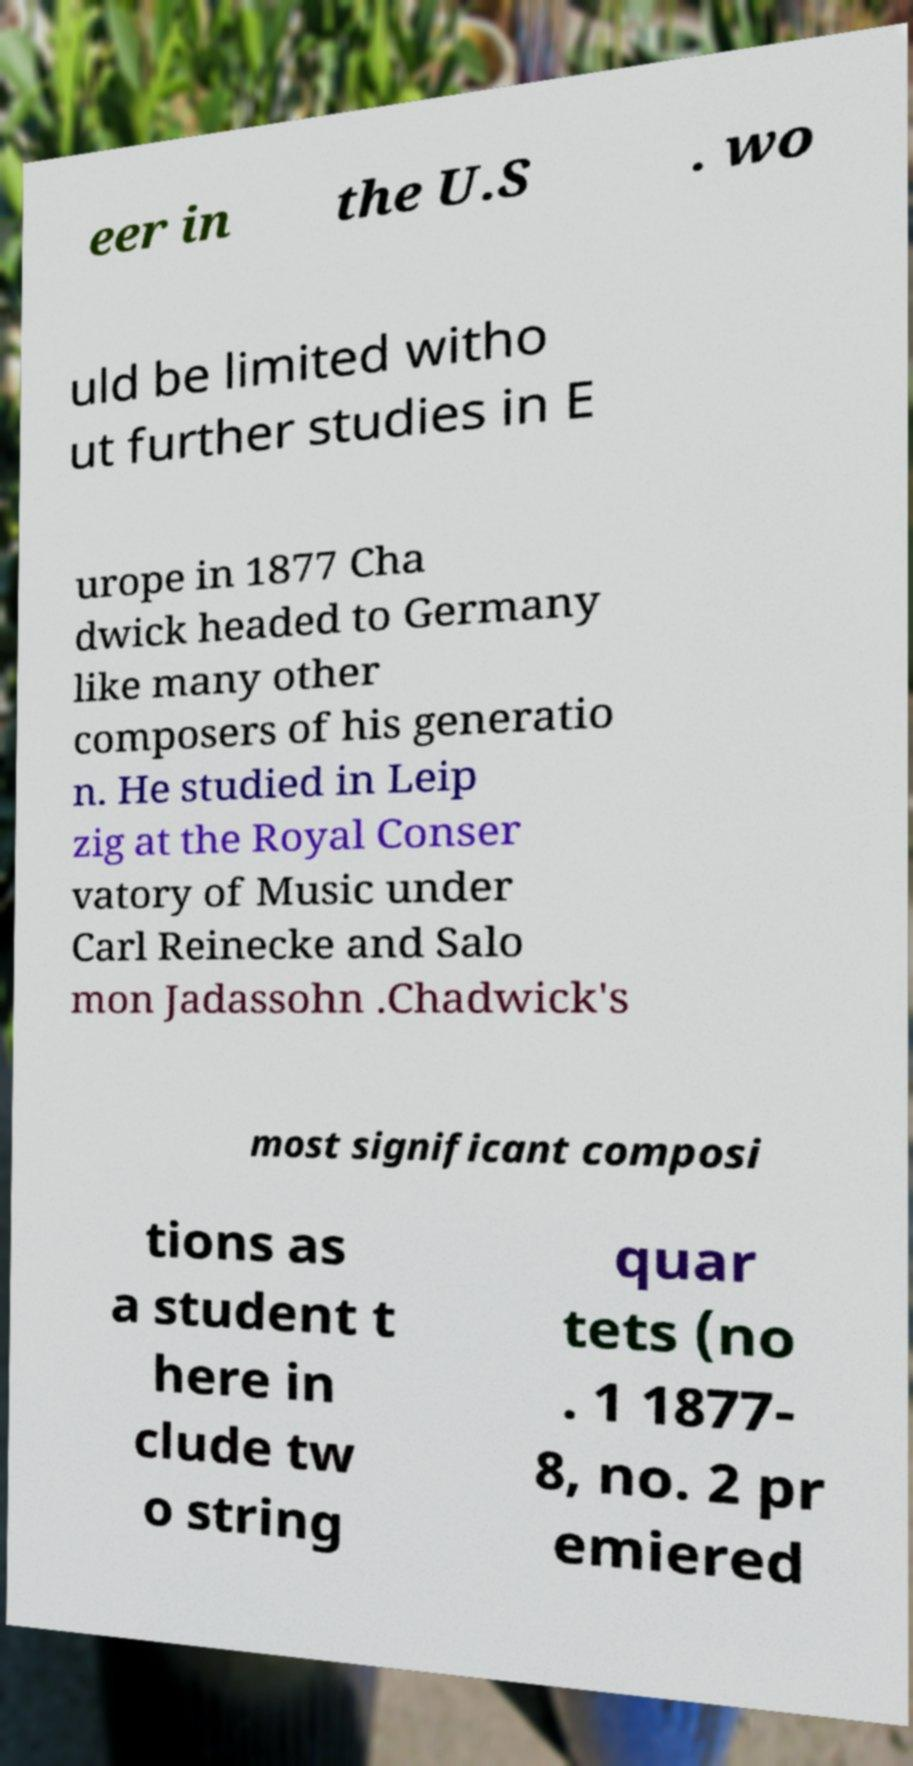Could you extract and type out the text from this image? eer in the U.S . wo uld be limited witho ut further studies in E urope in 1877 Cha dwick headed to Germany like many other composers of his generatio n. He studied in Leip zig at the Royal Conser vatory of Music under Carl Reinecke and Salo mon Jadassohn .Chadwick's most significant composi tions as a student t here in clude tw o string quar tets (no . 1 1877- 8, no. 2 pr emiered 